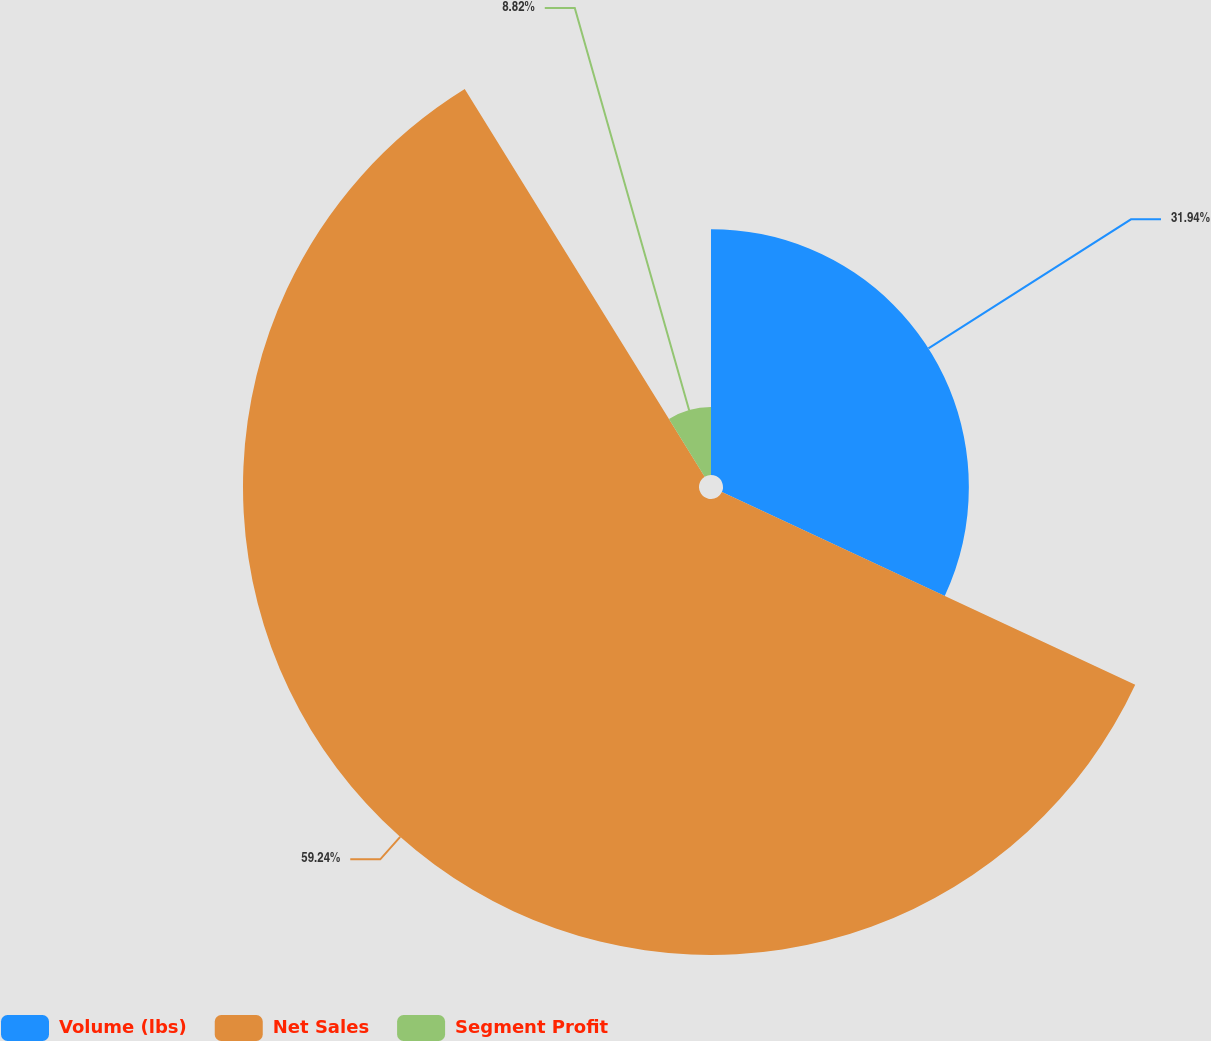<chart> <loc_0><loc_0><loc_500><loc_500><pie_chart><fcel>Volume (lbs)<fcel>Net Sales<fcel>Segment Profit<nl><fcel>31.94%<fcel>59.24%<fcel>8.82%<nl></chart> 